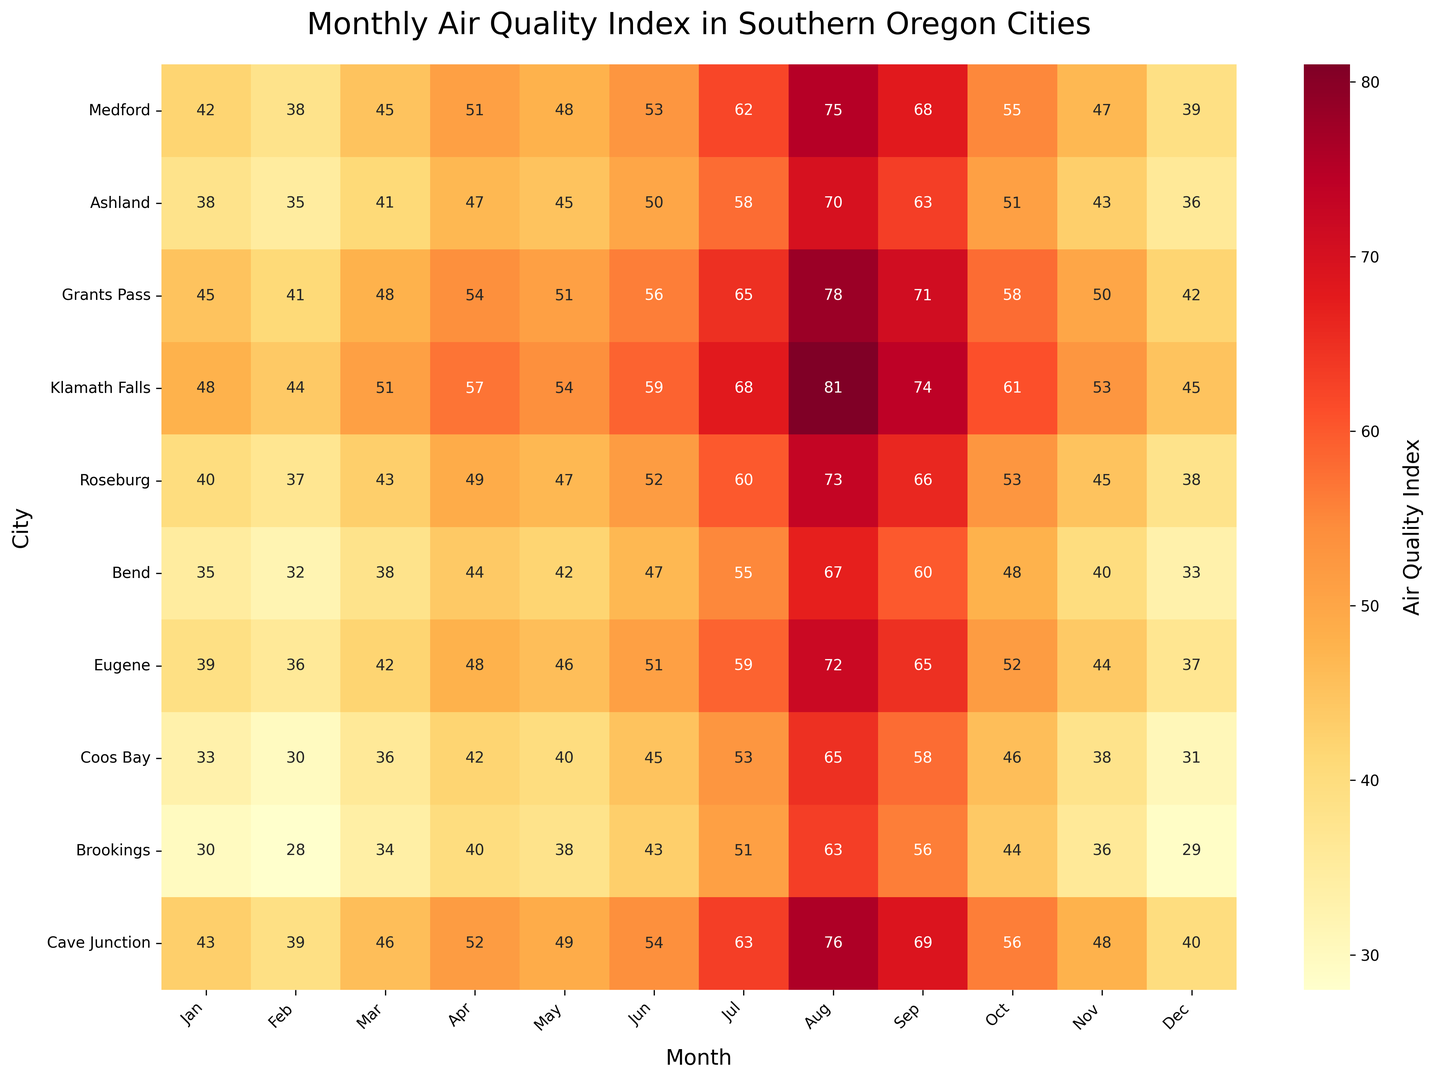Which city has the highest Air Quality Index (AQI) in August? To find this, look at the August column and identify the highest value. It is 81 in Klamath Falls.
Answer: Klamath Falls How does the AQI in Medford in July compare to the AQI in Ashland in the same month? Find the July values for Medford and Ashland. Medford's AQI is 62, and Ashland's is 58, so Medford's is higher.
Answer: Medford's is higher What is the average AQI of Eugene in the summer months (June, July, August)? Sum the AQI values for Eugene in June (51), July (59), and August (72). Divide by 3. (51+59+72)/3 = 60.67
Answer: 60.67 Which city has the lowest AQI in the winter months (Jan, Feb, Dec)? Look at the AQI values for January, February, and December across all cities. The lowest value is 28 in Brookings, in February.
Answer: Brookings Is there any city with a consistent AQI lower than 40 throughout the year? Check each city's AQI values in all months. None of the cities consistently have an AQI below 40 throughout the entire year.
Answer: No Compare the AQI values for Roseburg and Bend in October. Which city has a higher AQI? Find the October values for Roseburg (53) and Bend (48). Roseburg's AQI is higher.
Answer: Roseburg What is the difference in AQI between Grants Pass and Coos Bay in September? Look at the September values for Grants Pass (71) and Coos Bay (58). Subtract Coos Bay's AQI from Grants Pass' AQI: 71 - 58 = 13.
Answer: 13 Identify the month with the highest average AQI across all cities. Calculate the average AQI for each month by summing each month's values and dividing by the number of cities (10). August has the highest average, with values creating the highest mean AQI.
Answer: August How does the AQI in Brookings compare between winter (Dec-Feb) and summer (Jun-Aug)? Sum Brookings' AQI values for December, January, and February (29+30+28) = 87. Summer values for June, July, and August are (43+51+63) = 157. Compare 87 to 157, showing summertime is higher.
Answer: Summer is higher Which city shows the most significant increase in AQI from January to August? Calculate the increase for each city by subtracting January's value from August's value. The largest increase is in Klamath Falls, rising from 48 in January to 81 in August, an increase of 33.
Answer: Klamath Falls 